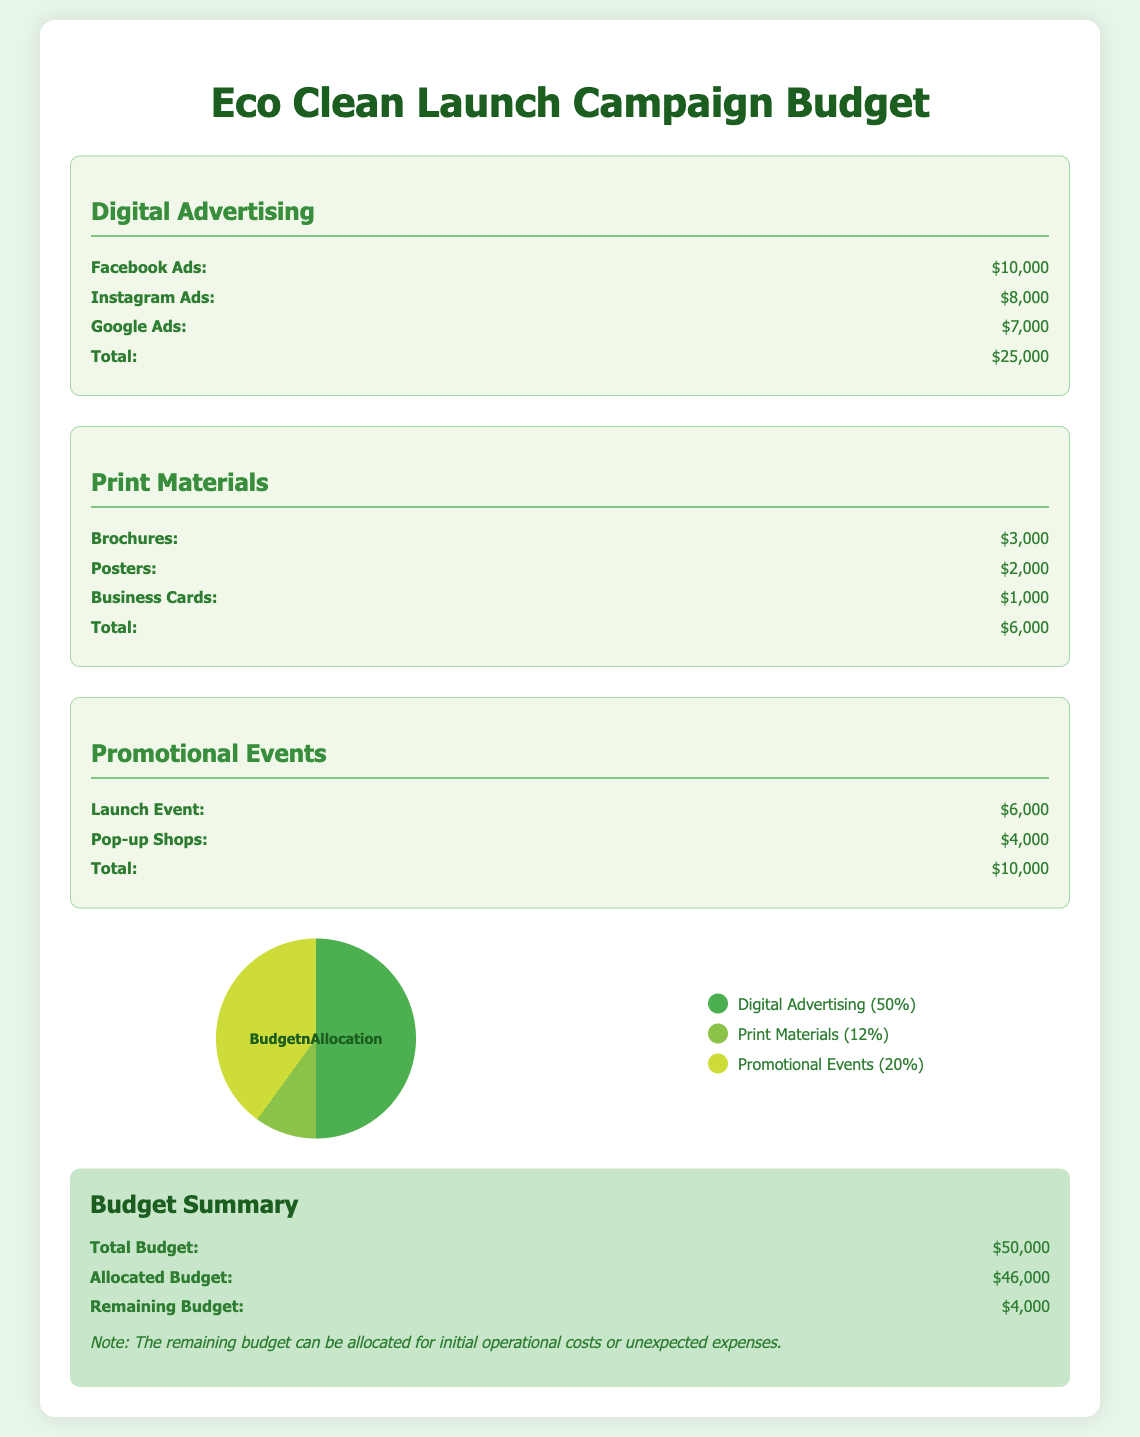What is the total budget allocated for digital advertising? The total budget for digital advertising is provided in the document in the respective section, which totals $25,000.
Answer: $25,000 How much is allocated for print materials? The section for print materials lists their total allocation, which is $6,000.
Answer: $6,000 What is the cost for Google Ads? The document specifies the individual cost for Google Ads under the digital advertising section, which is $7,000.
Answer: $7,000 How much is spent on the launch event? The launch event cost is detailed in the promotional events section, which is $6,000.
Answer: $6,000 What percentage of the budget is allocated to promotional events? The document includes a legend that indicates the percentage of the budget for promotional events, which is 20%.
Answer: 20% What is the remaining budget after allocations? The summary section of the document provides the remaining budget after allocations, which is $4,000.
Answer: $4,000 Which category has the highest budget allocation? The document provides a clear breakdown of budget allocations, indicating that digital advertising has the highest allocation.
Answer: Digital Advertising What is the cost for brochures? The document states the cost for brochures under the print materials section, which is $3,000.
Answer: $3,000 What is the total budget for the campaign? The total budget for the campaign is specified in the summary section of the document, totaling $50,000.
Answer: $50,000 